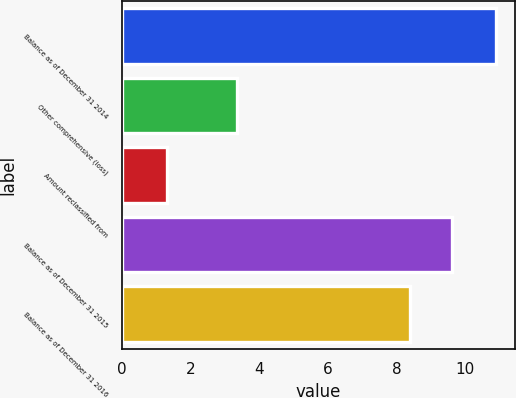<chart> <loc_0><loc_0><loc_500><loc_500><bar_chart><fcel>Balance as of December 31 2014<fcel>Other comprehensive (loss)<fcel>Amount reclassified from<fcel>Balance as of December 31 2015<fcel>Balance as of December 31 2016<nl><fcel>10.9<fcel>3.34<fcel>1.3<fcel>9.6<fcel>8.4<nl></chart> 